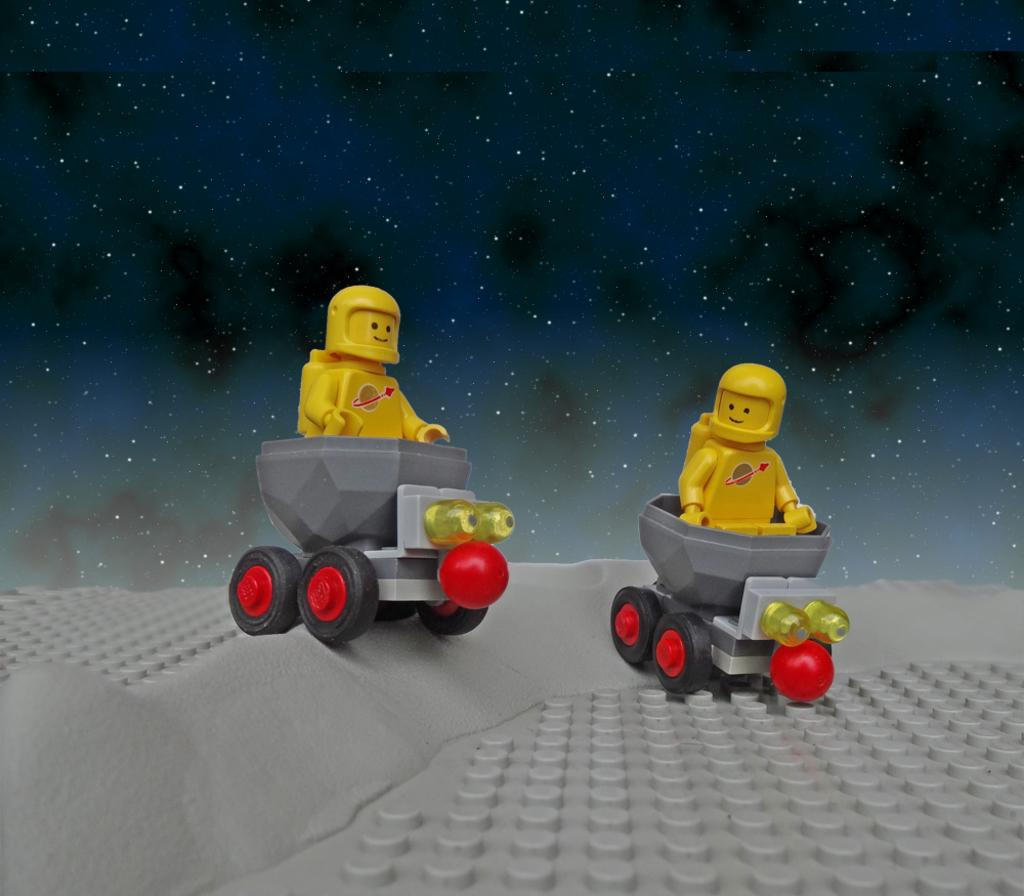What type of toys can be seen in the image? There are two toy cars in the image. What other objects are present in the image? There are dolls in the image. What color are the dolls? The dolls are yellow in color. What can be seen in the background of the image? There is an animated sky in the background of the image. What is depicted in the animated sky? The animated sky contains stars. Where is the hook located in the image? There is no hook present in the image. What type of books can be seen in the library in the image? There is no library present in the image. How many frogs are visible in the image? There are no frogs visible in the image. 